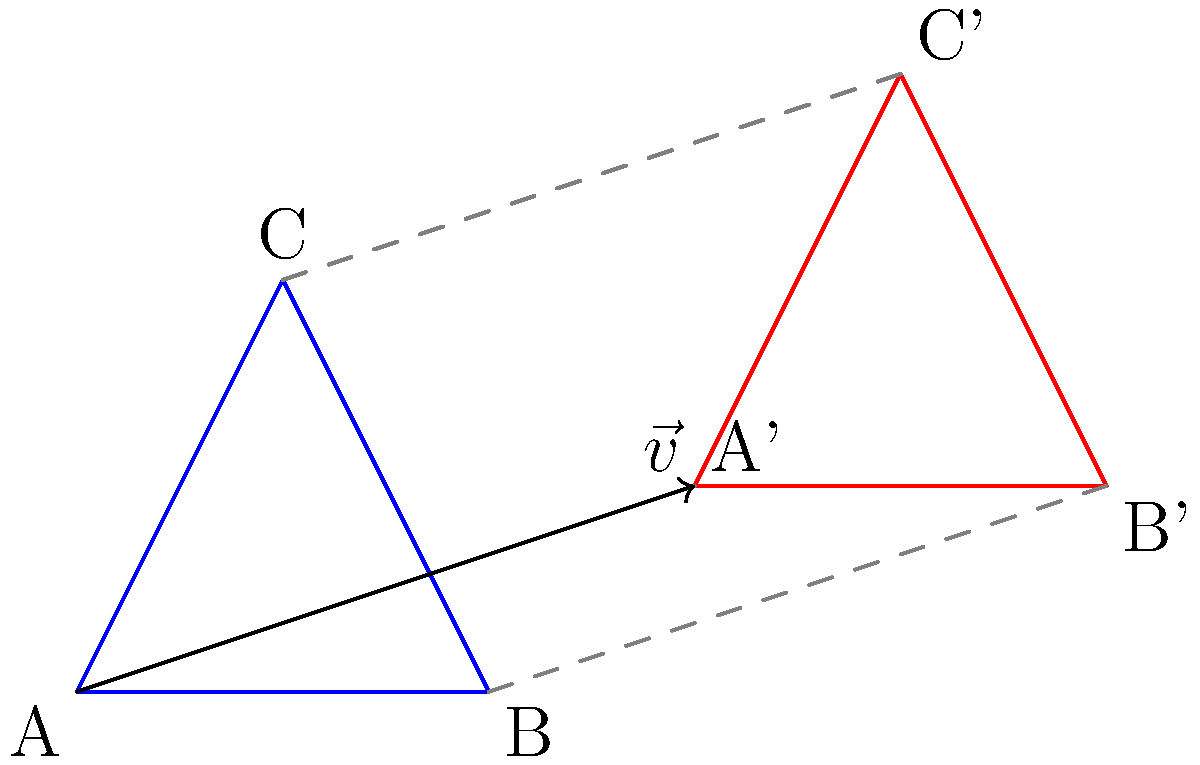As a forum moderator and beta tester, you've encountered a bug in a CAD software's transformation feature. To replicate the issue, you need to translate triangle ABC along vector $\vec{v} = (3,1)$. Given that A(0,0), B(2,0), and C(1,2), what are the coordinates of point C' (the translated position of C)? To find the coordinates of C' after translating triangle ABC along vector $\vec{v} = (3,1)$, we follow these steps:

1. Identify the initial coordinates of point C: (1,2)
2. Recognize the translation vector $\vec{v} = (3,1)$
3. Apply the translation formula: For any point (x,y), its translated position (x',y') is given by:
   $x' = x + v_x$
   $y' = y + v_y$
   Where $v_x$ and $v_y$ are the x and y components of the translation vector, respectively.
4. Calculate the new coordinates:
   $x' = 1 + 3 = 4$
   $y' = 2 + 1 = 3$
5. Therefore, the coordinates of C' are (4,3)

This method of adding the vector components to the original coordinates is consistent across all points in the triangle, ensuring the shape is preserved during translation.
Answer: (4,3) 